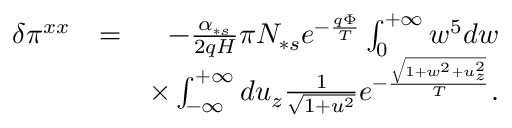Convert formula to latex. <formula><loc_0><loc_0><loc_500><loc_500>\begin{array} { r l r } { \delta \pi ^ { x x } } & { = } & { - \frac { \alpha _ { \ast s } } { 2 q H } \pi N _ { \ast s } e ^ { - \frac { q \Phi } { T } } \int _ { 0 } ^ { + \infty } w ^ { 5 } d w } \\ & { \times \int _ { - \infty } ^ { + \infty } d u _ { z } \frac { 1 } { \sqrt { 1 + u ^ { 2 } } } e ^ { - \frac { \sqrt { 1 + w ^ { 2 } + u _ { z } ^ { 2 } } } { T } } . } \end{array}</formula> 